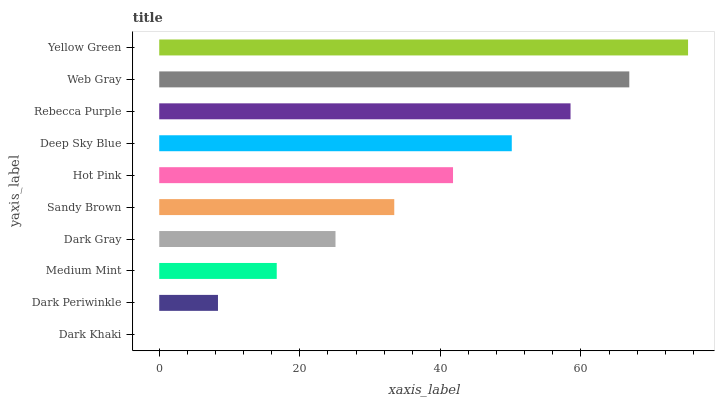Is Dark Khaki the minimum?
Answer yes or no. Yes. Is Yellow Green the maximum?
Answer yes or no. Yes. Is Dark Periwinkle the minimum?
Answer yes or no. No. Is Dark Periwinkle the maximum?
Answer yes or no. No. Is Dark Periwinkle greater than Dark Khaki?
Answer yes or no. Yes. Is Dark Khaki less than Dark Periwinkle?
Answer yes or no. Yes. Is Dark Khaki greater than Dark Periwinkle?
Answer yes or no. No. Is Dark Periwinkle less than Dark Khaki?
Answer yes or no. No. Is Hot Pink the high median?
Answer yes or no. Yes. Is Sandy Brown the low median?
Answer yes or no. Yes. Is Dark Periwinkle the high median?
Answer yes or no. No. Is Deep Sky Blue the low median?
Answer yes or no. No. 